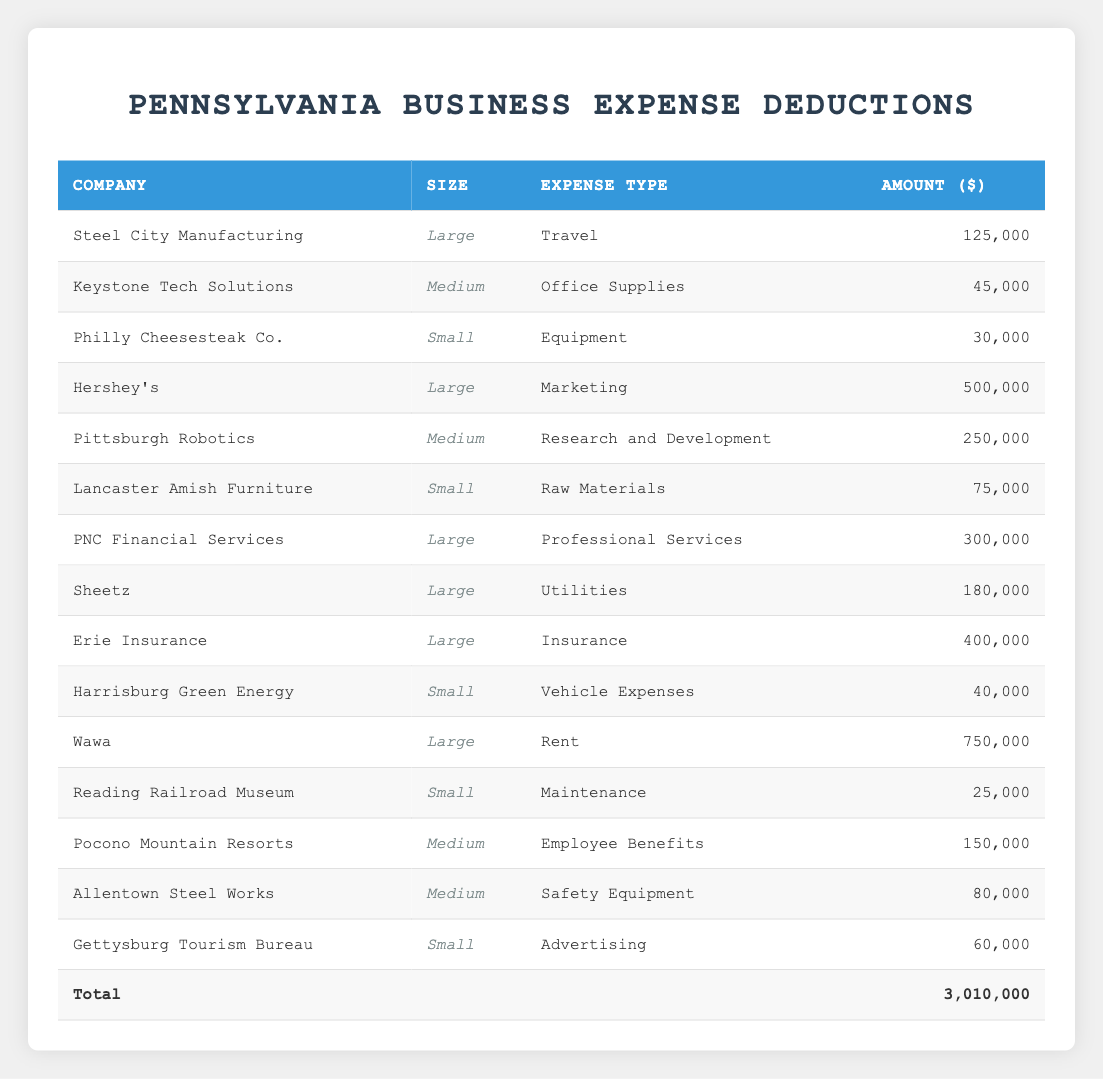What is the total expense amount for large companies? To find the total expense for large companies, I will sum the amounts from the rows corresponding to large companies: 125,000 + 500,000 + 300,000 + 180,000 + 400,000 + 750,000 = 2,455,000
Answer: 2,455,000 Which company had the highest expense for marketing? The only entry for marketing is from Hershey's, which shows an expense amount of 500,000. Therefore, it is the highest.
Answer: Hershey's Is there any small company with expenses for utilities? In the table, there are no entries for utilities related to small companies, only large companies have this expense type.
Answer: No How much does the small company "Lancaster Amish Furniture" spend on raw materials? The row for Lancaster Amish Furniture shows an expense amount of 75,000 for raw materials.
Answer: 75,000 What is the average expense amount for medium-sized companies? To calculate the average, I identify the total expenses of medium-sized companies: 45,000 + 250,000 + 150,000 + 80,000 = 525,000. There are four medium companies, so the average is 525,000 divided by 4, which equals 131,250.
Answer: 131,250 Which expense type has the highest total among large companies? For large companies: Travel (125,000), Marketing (500,000), Professional Services (300,000), Utilities (180,000), Insurance (400,000), Rent (750,000). The highest total comes from Rent, which is 750,000.
Answer: Rent Do any medium companies have expenses for office supplies? The table shows that Keystone Tech Solutions spends 45,000 on office supplies, which confirms that a medium company does have expenses for this type.
Answer: Yes How much more does Wawa spend on rent compared to Harrisburg Green Energy's vehicle expenses? Wawa spends 750,000 on rent and Harrisburg Green Energy spends 40,000 on vehicle expenses. The difference is 750,000 - 40,000 = 710,000.
Answer: 710,000 What is the total amount spent on advertising by small companies? Only Gettysburg Tourism Bureau spends on advertising with an amount of 60,000. There are no other small companies with this expense type, so the total is 60,000.
Answer: 60,000 